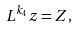<formula> <loc_0><loc_0><loc_500><loc_500>L ^ { k _ { 4 } } z = Z ,</formula> 